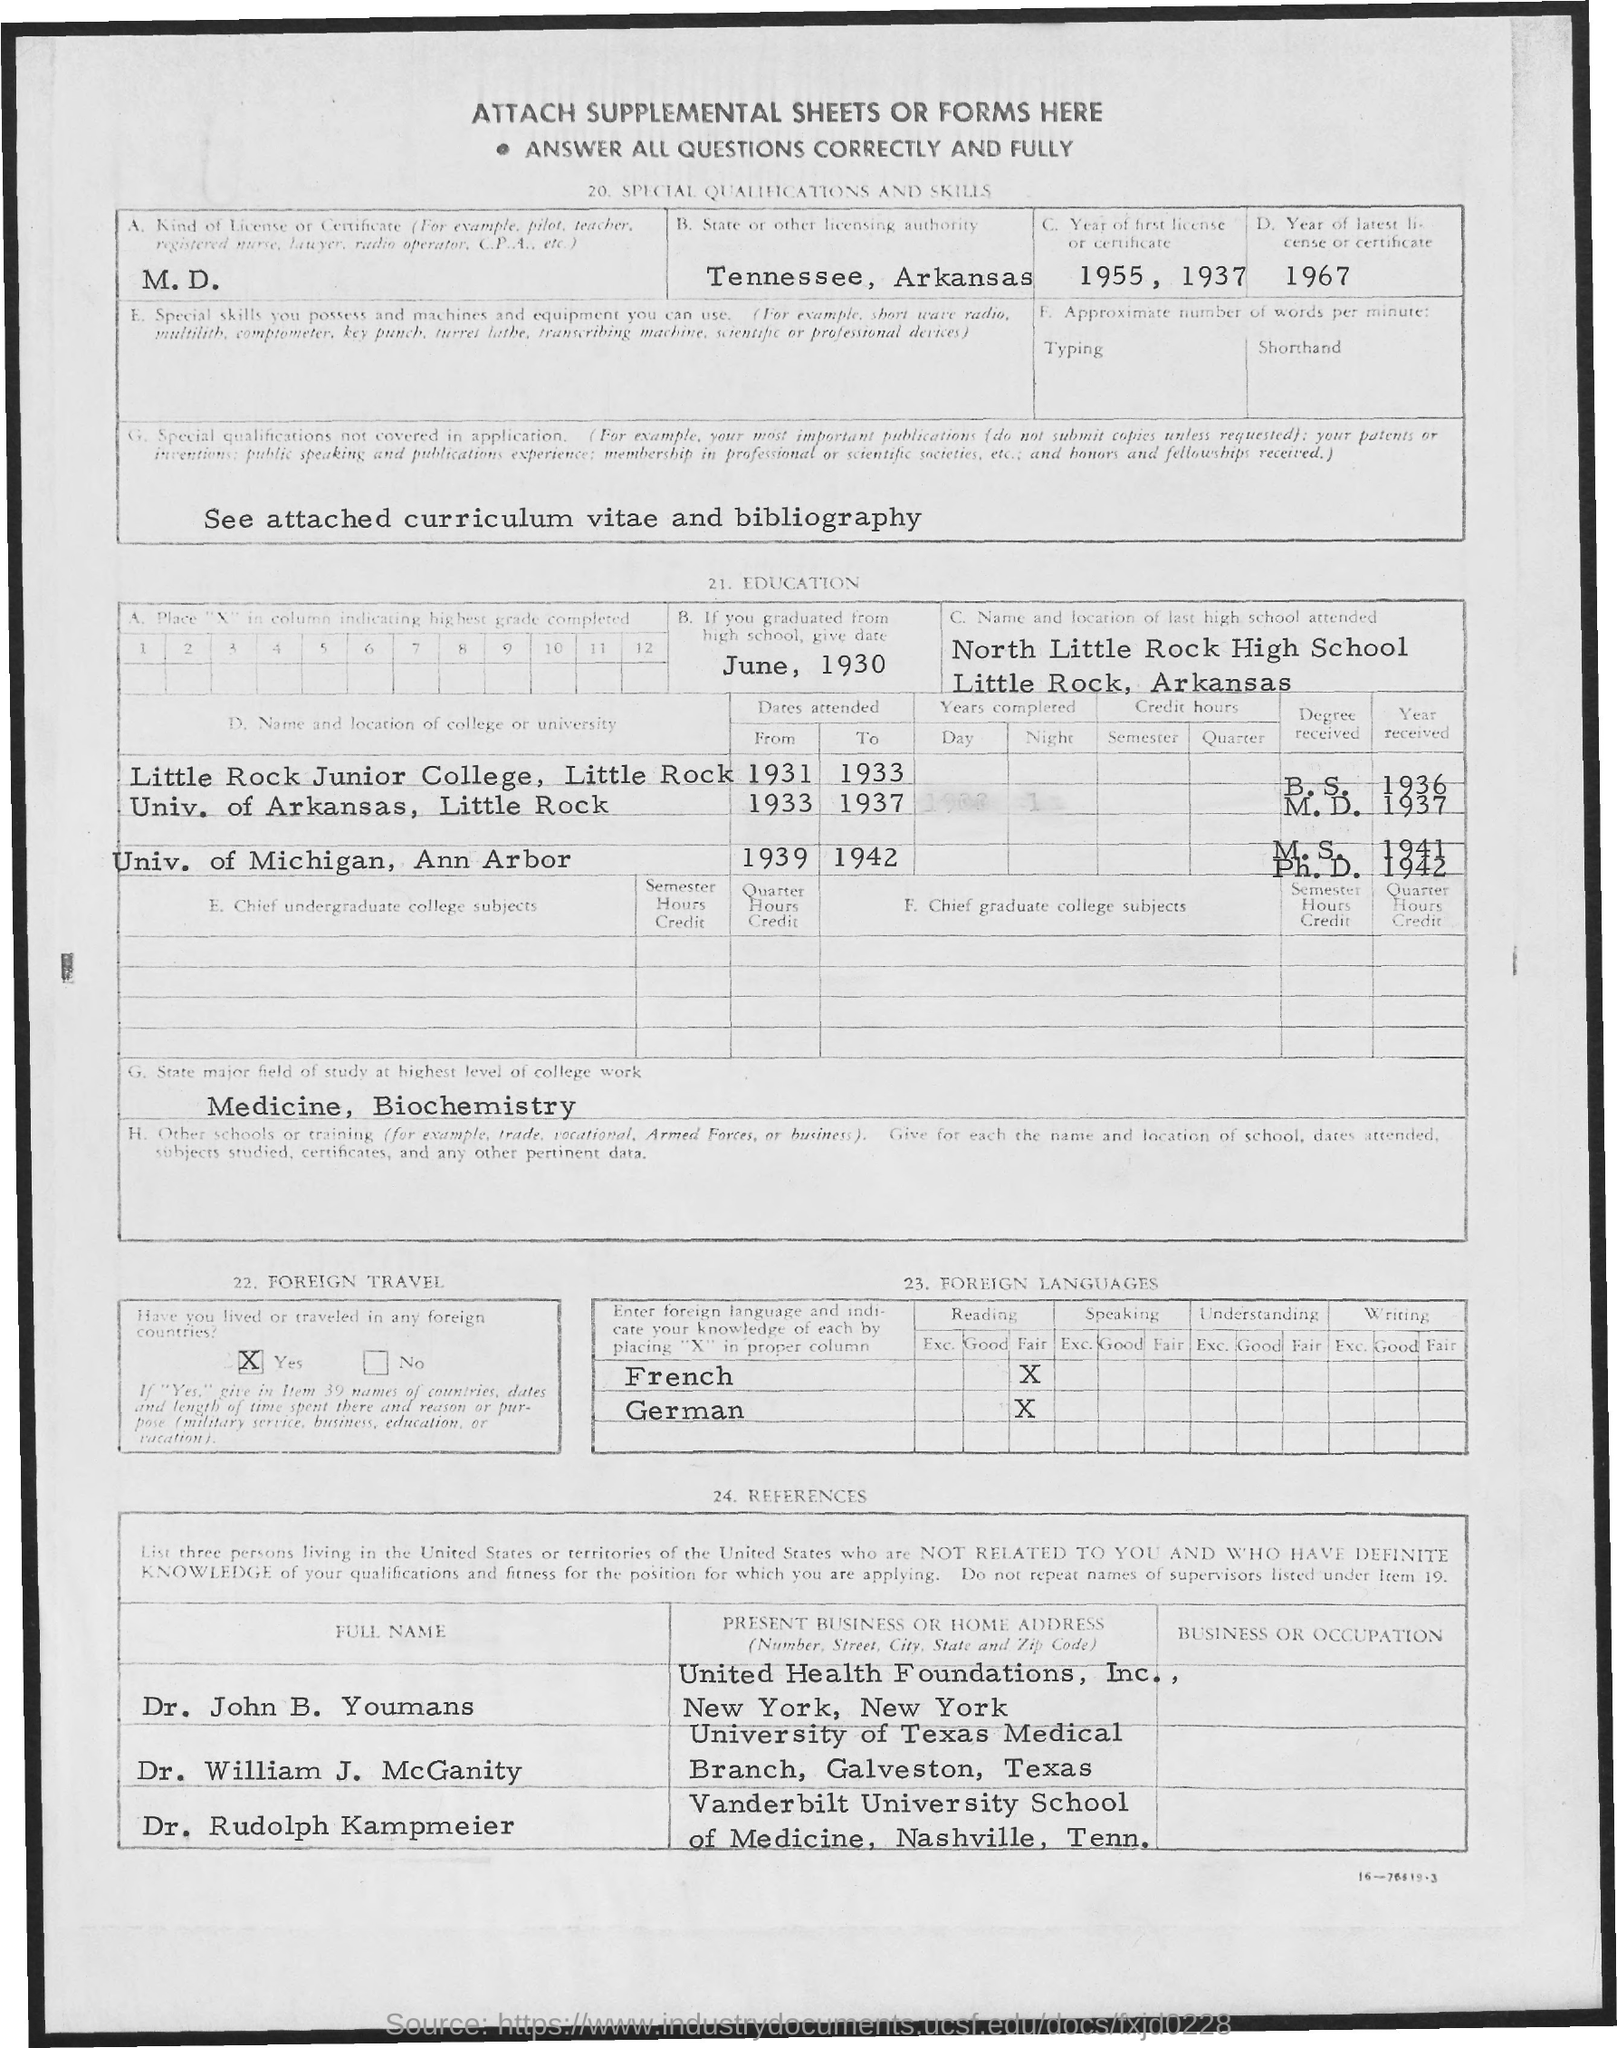List a handful of essential elements in this visual. I attended high school in Little Rock, Arkansas. I attended North Little Rock High School, which was the name of the last high school I attended. The major field of study at the highest level of college work is known as medicine and biochemistry. The first title in the document is ATTACH SUPPLEMENTAL SHEETS OR FORMS HERE. The type of license for M.D. is... 